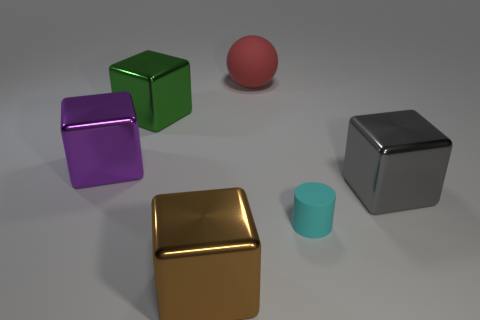Why might the spherical object be included among these cubes? Including a sphere among cubes creates a contrast in geometry and form, emphasizing the unique qualities of each shape. The sphere, with its continuous surface and absence of edges or vertices, offers a visual and conceptual variety to the scene. 